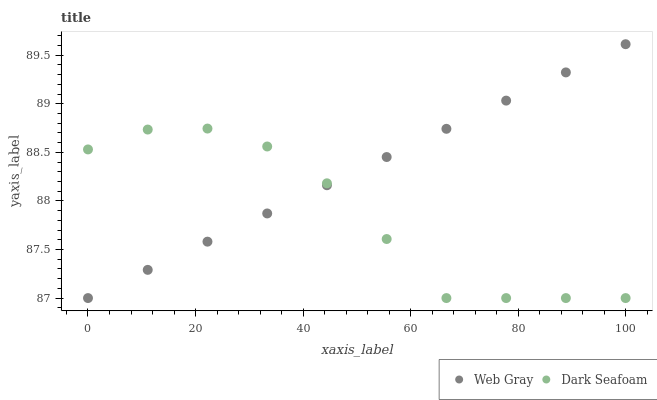Does Dark Seafoam have the minimum area under the curve?
Answer yes or no. Yes. Does Web Gray have the maximum area under the curve?
Answer yes or no. Yes. Does Web Gray have the minimum area under the curve?
Answer yes or no. No. Is Web Gray the smoothest?
Answer yes or no. Yes. Is Dark Seafoam the roughest?
Answer yes or no. Yes. Is Web Gray the roughest?
Answer yes or no. No. Does Dark Seafoam have the lowest value?
Answer yes or no. Yes. Does Web Gray have the highest value?
Answer yes or no. Yes. Does Web Gray intersect Dark Seafoam?
Answer yes or no. Yes. Is Web Gray less than Dark Seafoam?
Answer yes or no. No. Is Web Gray greater than Dark Seafoam?
Answer yes or no. No. 